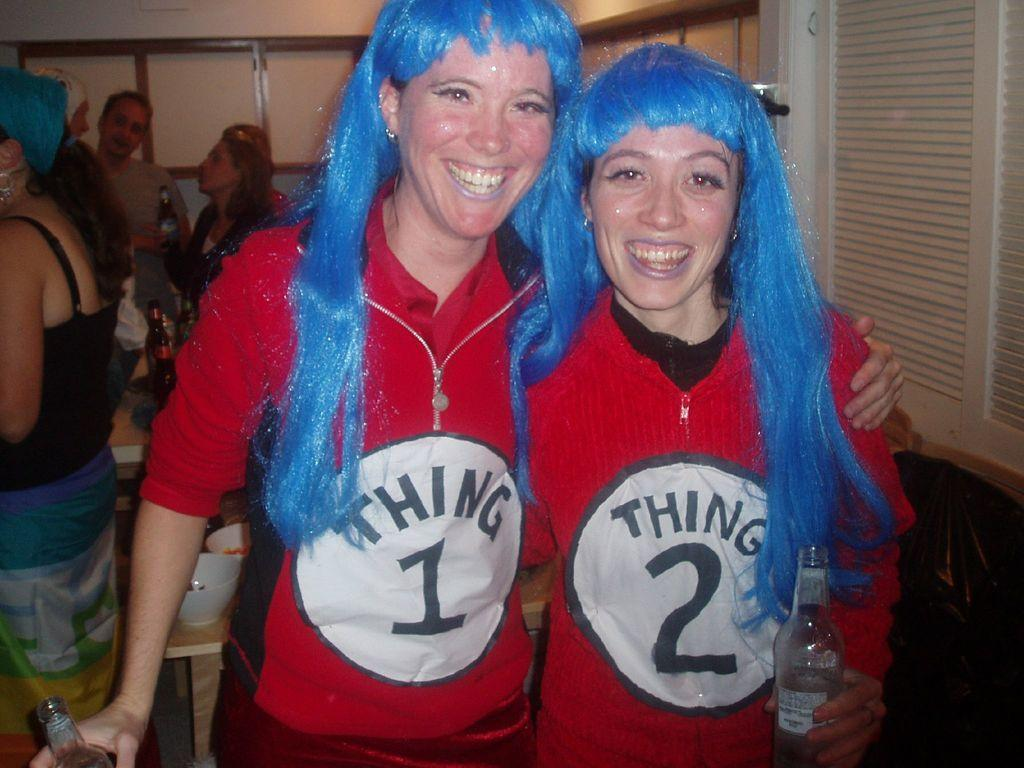<image>
Relay a brief, clear account of the picture shown. two girls wearing shirts that say 'thing 1' and 'thing 2' on them 